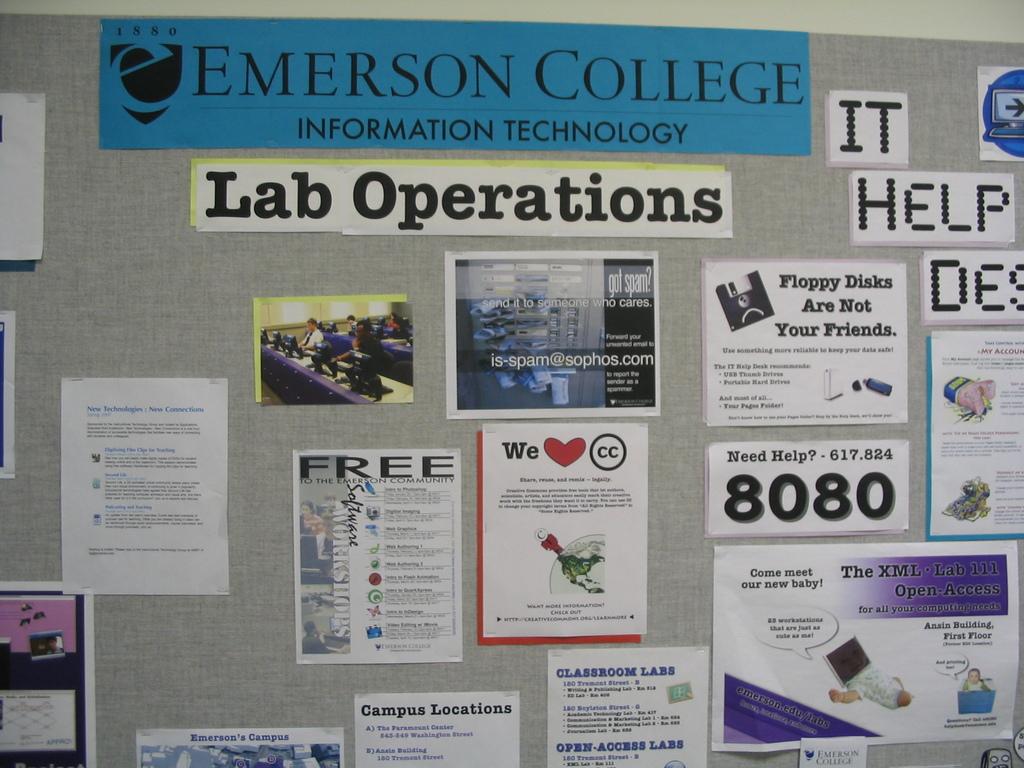What college is this?
Offer a terse response. Emerson college. What kind of operations are posted?
Keep it short and to the point. Lab operations. 